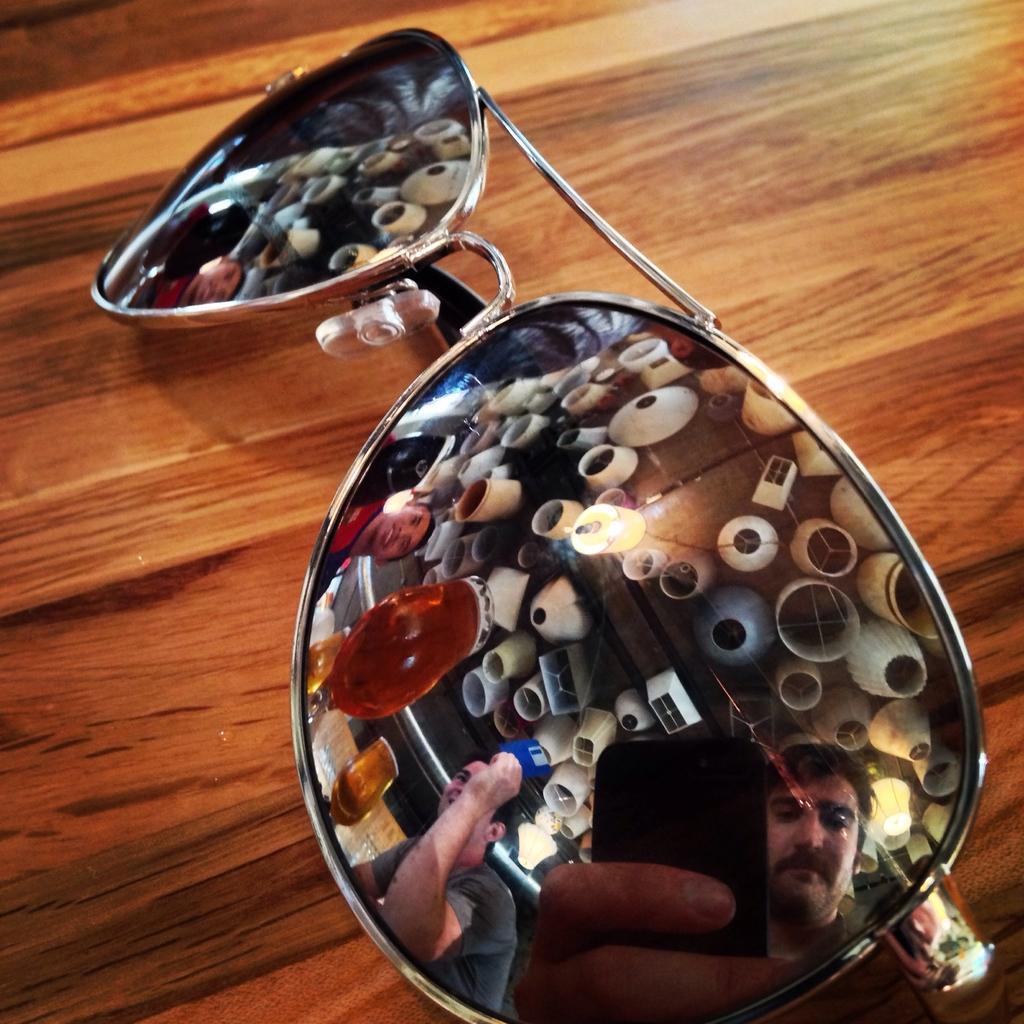Could you give a brief overview of what you see in this image? This picture is of inside the room. In the center we can see the sun glasses placed on the top of the table and we can see the reflection of a man holding a mobile phone, lamps, glasses containing drinks and two other persons. 